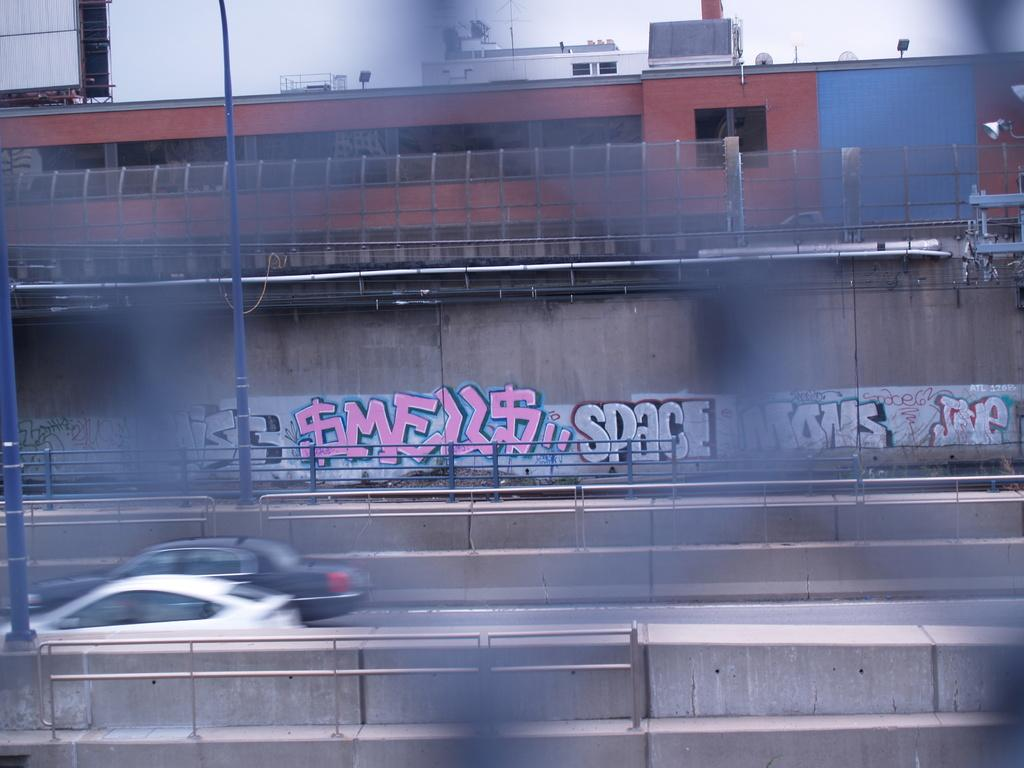<image>
Describe the image concisely. A picture taken through a fence shows the word "Space" in graffiti. 